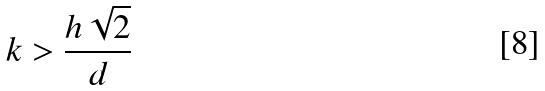Convert formula to latex. <formula><loc_0><loc_0><loc_500><loc_500>k > \frac { h \sqrt { 2 } } { d }</formula> 